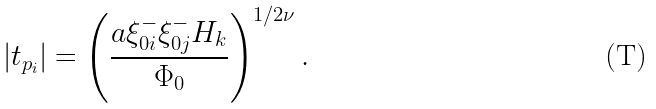Convert formula to latex. <formula><loc_0><loc_0><loc_500><loc_500>\left | t _ { p _ { i } } \right | = \left ( \frac { a \xi _ { 0 i } ^ { - } \xi _ { 0 j } ^ { - } H _ { k } } { \Phi _ { 0 } } \right ) ^ { 1 / 2 \nu } .</formula> 